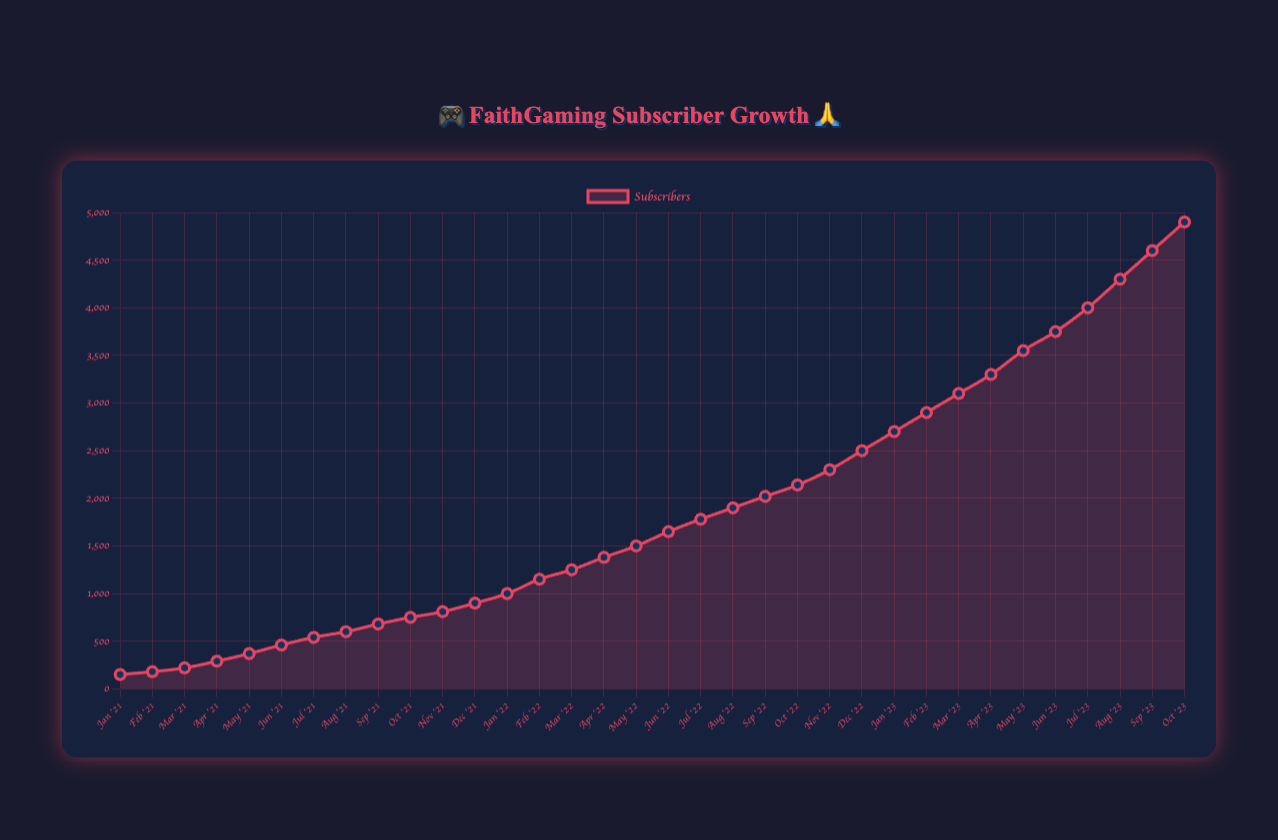What is the total number of subscribers the channel had by the end of 2021? Look at the value for December 2021 on the chart, which shows the number of subscribers as 900.
Answer: 900 In which month of 2021 did the channel have the highest increase in subscribers compared to the previous month? Calculate the difference in subscribers month-over-month for the year 2021 and identify the month with the highest increase. The increase in each month: Feb: 30, Mar: 40, Apr: 70, May: 80, Jun: 90, Jul: 80, Aug: 60, Sep: 80, Oct: 70, Nov: 60, Dec: 90. The highest increase is in June 2021 with 90 new subscribers.
Answer: June 2021 What was the average monthly increase in subscribers from January 2021 to October 2021? Calculate each monthly increase, sum them up and divide by the number of months (10). The increases are: 30, 40, 70, 80, 90, 80, 60, 80, 70, 60. Sum: 660. Average: 660/10.
Answer: 66 By how much did the number of subscribers increase from January 2022 to December 2022? Subscribers in January 2022: 1000, in December 2022: 2500. Difference: 2500 - 1000.
Answer: 1500 During which month in 2023 did the channel first exceed 3000 subscribers? Locate the month in 2023 where the subscribers first cross the 3000 mark. In April 2023, subscribers reach 3300.
Answer: April 2023 Which year showed the greatest overall growth in subscribers? Compare the total increase in subscribers for each year: 2021: 900 - 150 = 750, 2022: 2500 - 1000 = 1500, 2023: 4900 - 2700 = 2200. The greatest growth is in 2023.
Answer: 2023 How many subscribers were there exactly halfway through 2022? Locate the subscriber count for June 2022. Subscribers were 1650 in June 2022.
Answer: 1650 Between which two months in 2022 did the channel see the steepest increase in subscribers? Calculate monthly increases and identify the steepest climb. Jan-Feb: 150, Feb-Mar: 100, Mar-Apr: 130, Apr-May: 120, May-Jun: 150, Jun-Jul: 130, Jul-Aug: 120, Aug-Sep: 120, Sep-Oct: 120, Oct-Nov: 160, Nov-Dec: 200. The steepest increase is between November and December 2022.
Answer: November to December What is the overall trend in the growth of followers from January 2021 to October 2023? Observe the plot. The overall trend shows a continuous and accelerating increase in followers over time.
Answer: Continuous and accelerating growth 